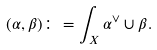<formula> <loc_0><loc_0><loc_500><loc_500>( \alpha , \beta ) \colon = \int _ { X } \alpha ^ { \vee } \cup \beta .</formula> 